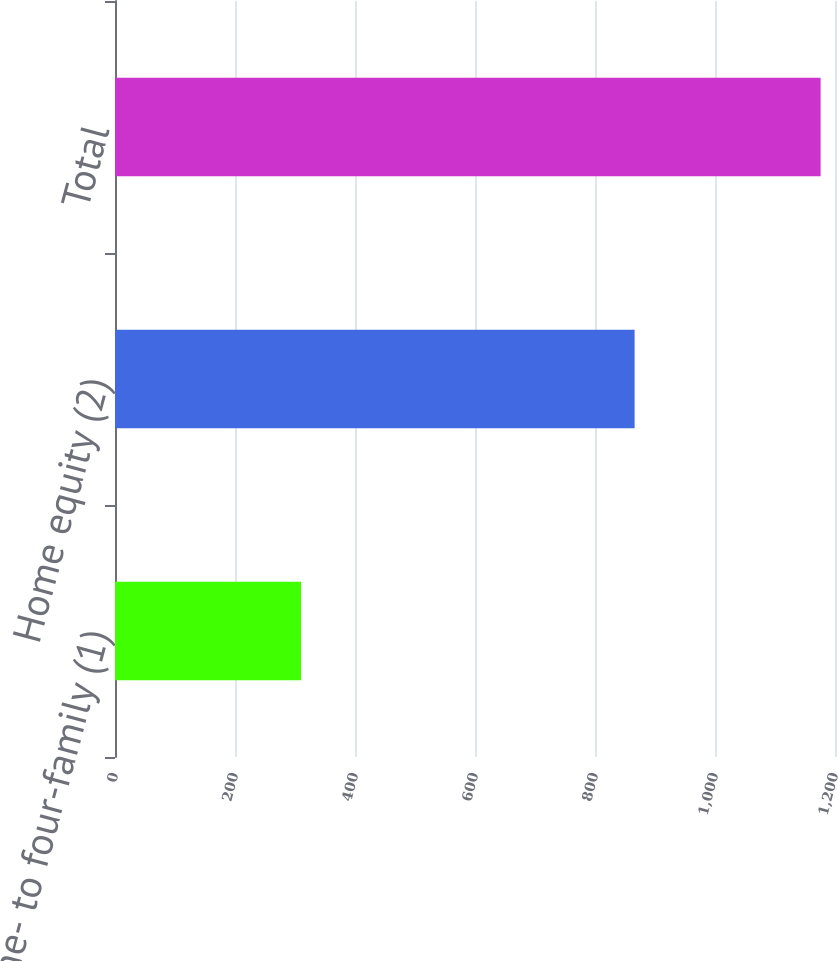Convert chart to OTSL. <chart><loc_0><loc_0><loc_500><loc_500><bar_chart><fcel>One- to four-family (1)<fcel>Home equity (2)<fcel>Total<nl><fcel>310<fcel>866<fcel>1176<nl></chart> 